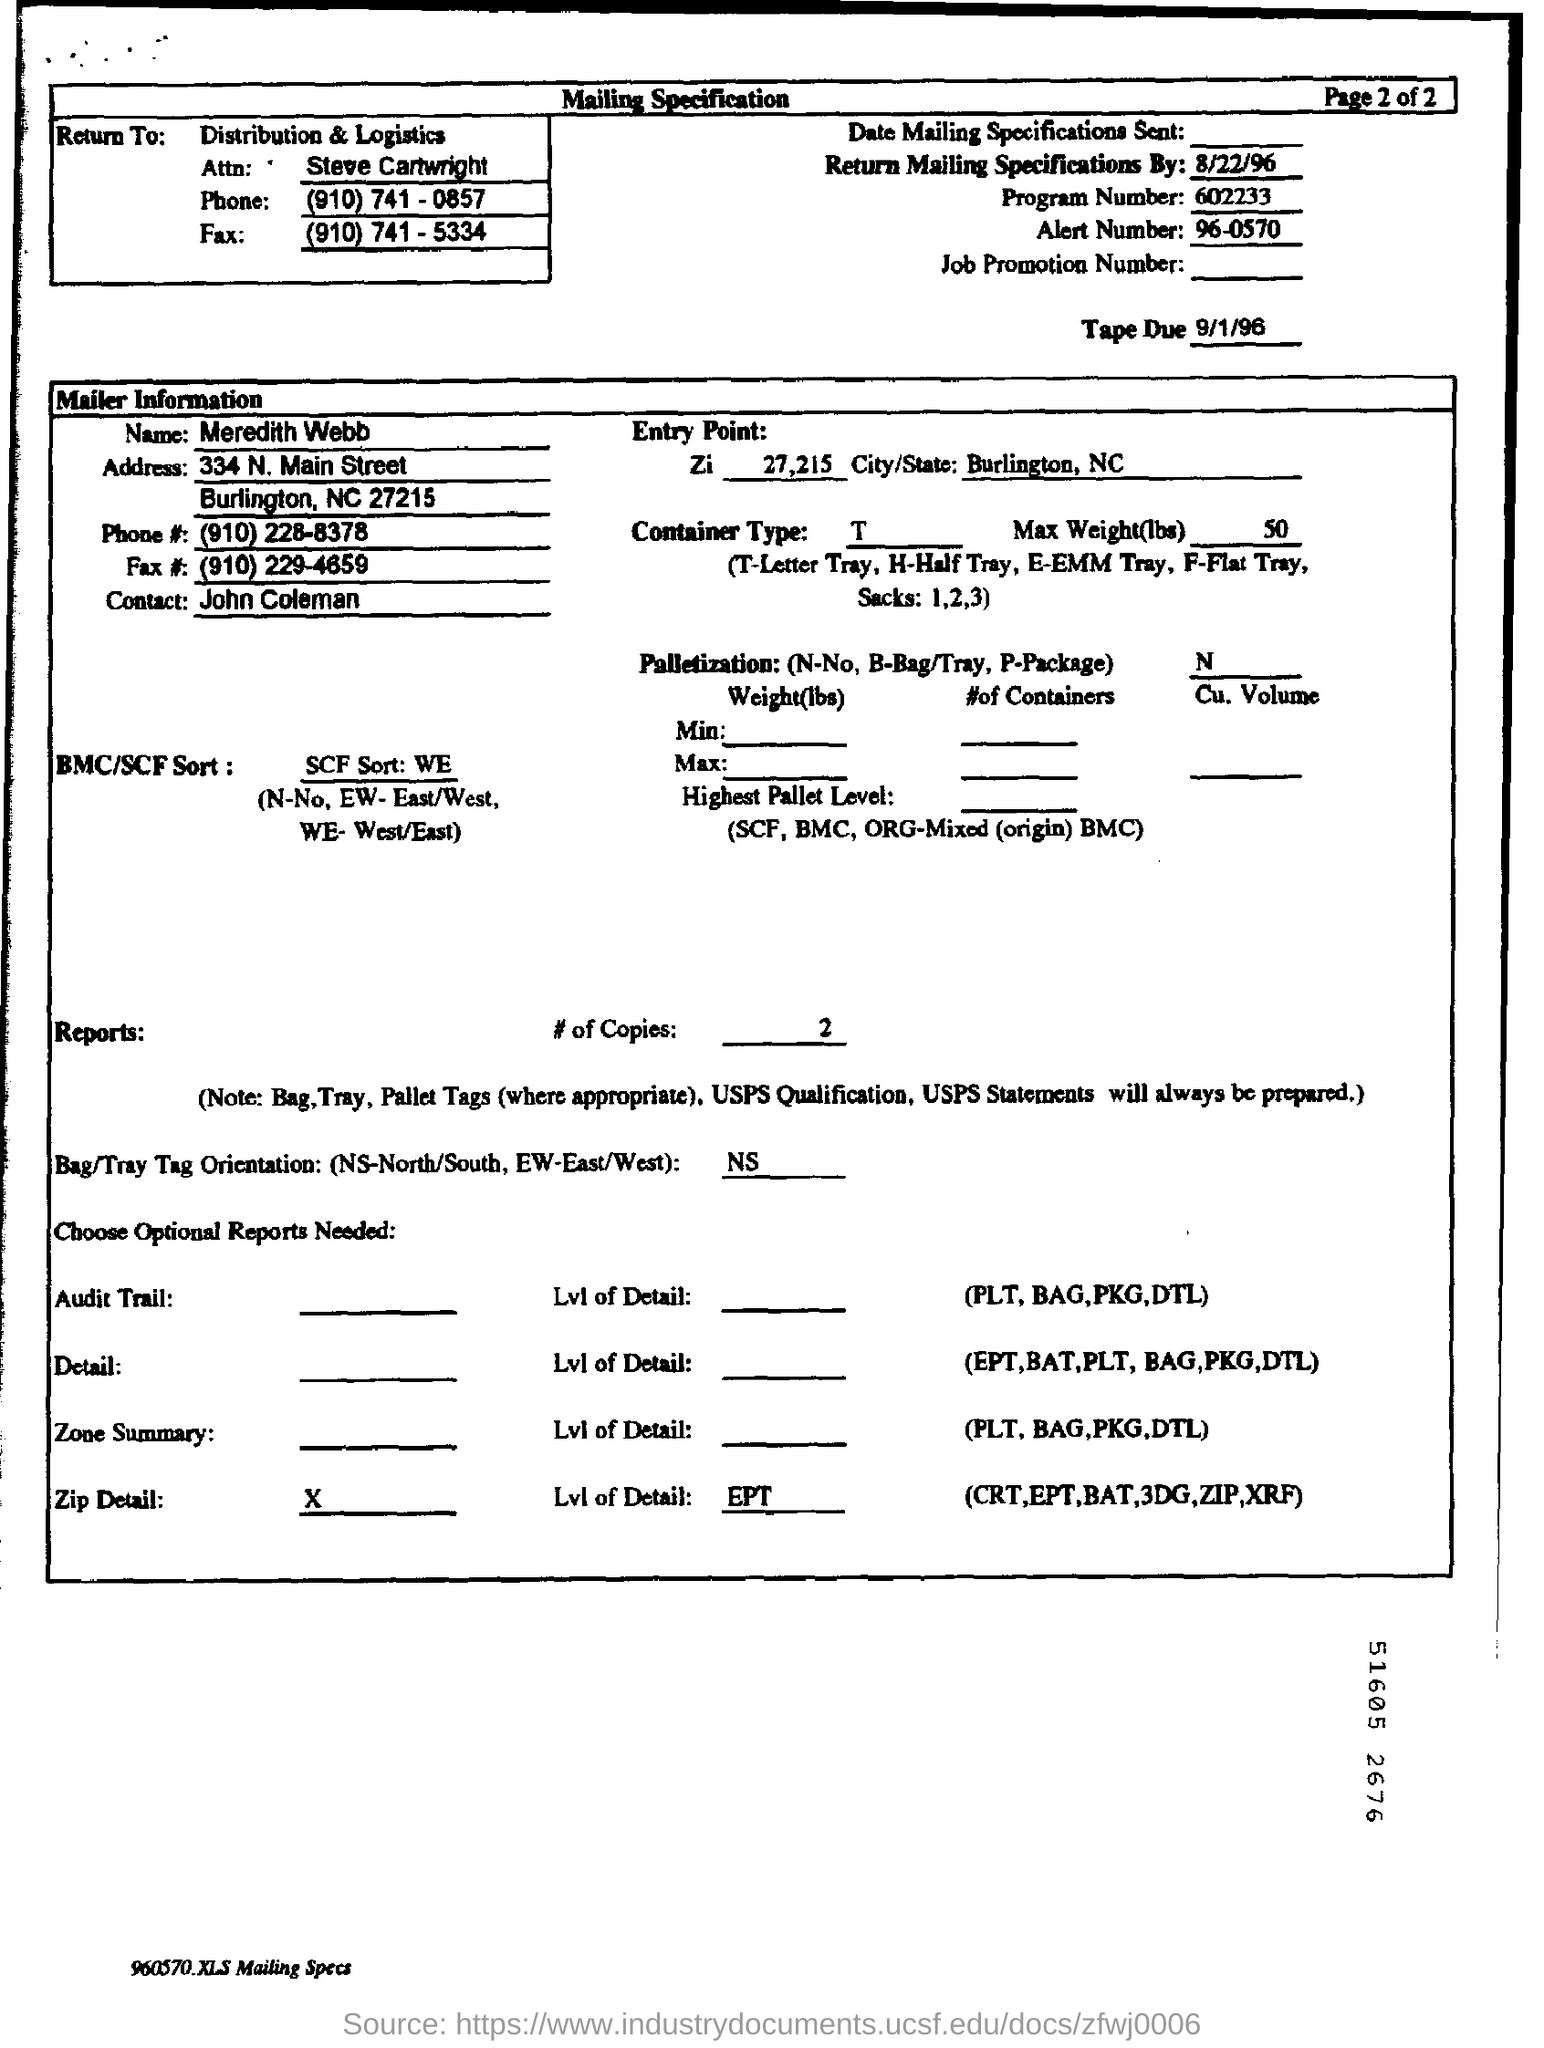Give some essential details in this illustration. The number of copies is two. What is the program number?" is a question that asks for information.
"602233..." is a series of characters that represents a number.
Together, the question and the number are asking for the program number. Please provide the alert number: 96-0570... 